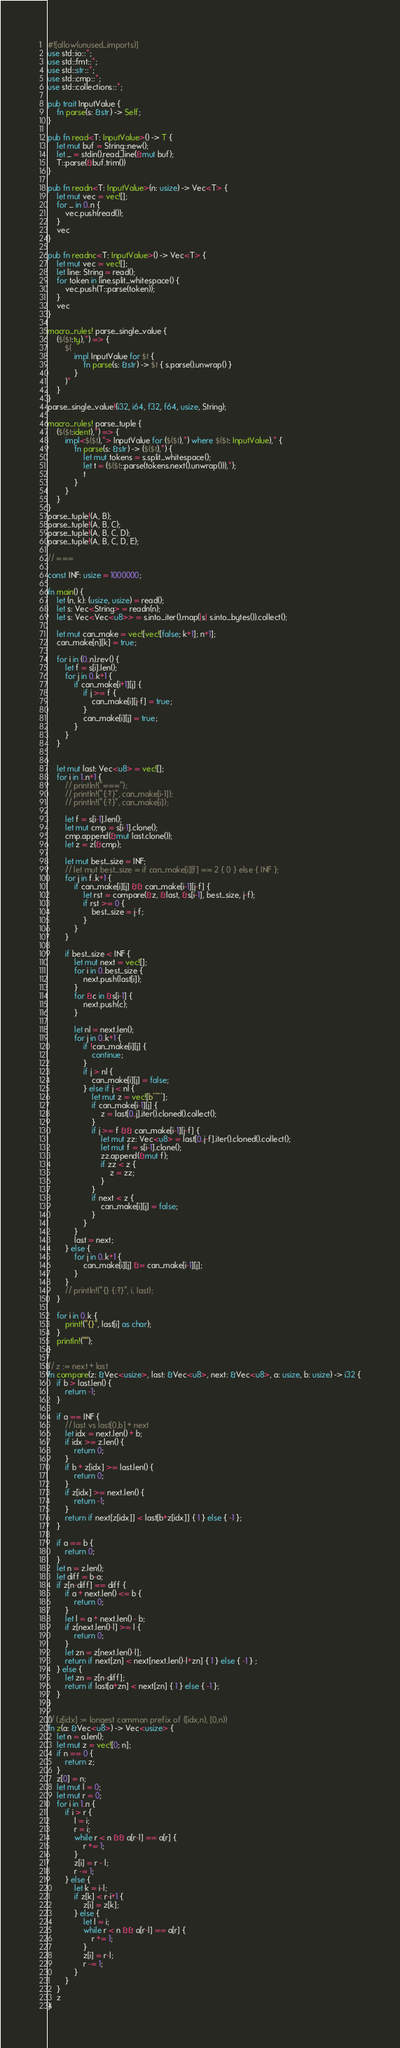<code> <loc_0><loc_0><loc_500><loc_500><_Rust_>#![allow(unused_imports)]
use std::io::*;
use std::fmt::*;
use std::str::*;
use std::cmp::*;
use std::collections::*;

pub trait InputValue {
    fn parse(s: &str) -> Self;
}

pub fn read<T: InputValue>() -> T {
    let mut buf = String::new();
    let _ = stdin().read_line(&mut buf);
    T::parse(&buf.trim())
}

pub fn readn<T: InputValue>(n: usize) -> Vec<T> {
    let mut vec = vec![];
    for _ in 0..n {
        vec.push(read());
    }
    vec
}

pub fn readnc<T: InputValue>() -> Vec<T> {
    let mut vec = vec![];
    let line: String = read();
    for token in line.split_whitespace() {
        vec.push(T::parse(token));
    }
    vec
}

macro_rules! parse_single_value {
    ($($t:ty),*) => {
        $(
            impl InputValue for $t {
                fn parse(s: &str) -> $t { s.parse().unwrap() }
            }
        )*
	}
}
parse_single_value!(i32, i64, f32, f64, usize, String);

macro_rules! parse_tuple {
	($($t:ident),*) => {
		impl<$($t),*> InputValue for ($($t),*) where $($t: InputValue),* {
			fn parse(s: &str) -> ($($t),*) {
				let mut tokens = s.split_whitespace();
				let t = ($($t::parse(tokens.next().unwrap())),*);
				t
			}
		}
	}
}
parse_tuple!(A, B);
parse_tuple!(A, B, C);
parse_tuple!(A, B, C, D);
parse_tuple!(A, B, C, D, E);

// ===

const INF: usize = 1000000;

fn main() {
    let (n, k): (usize, usize) = read();
    let s: Vec<String> = readn(n);
    let s: Vec<Vec<u8>> = s.into_iter().map(|s| s.into_bytes()).collect();

    let mut can_make = vec![vec![false; k+1]; n+1];
    can_make[n][k] = true;

    for i in (0..n).rev() {
        let f = s[i].len();
        for j in 0..k+1 {
            if can_make[i+1][j] {
                if j >= f {
                    can_make[i][j-f] = true;
                }
                can_make[i][j] = true;
            }
        }
    }


    let mut last: Vec<u8> = vec![];
    for i in 1..n+1 {
        // println!("===");
        // println!("{:?}", can_make[i-1]);
        // println!("{:?}", can_make[i]);

        let f = s[i-1].len();
        let mut cmp = s[i-1].clone();
        cmp.append(&mut last.clone());
        let z = z(&cmp);

        let mut best_size = INF;
        // let mut best_size = if can_make[i][f] == 2 { 0 } else { INF };
        for j in f..k+1 {
            if can_make[i][j] && can_make[i-1][j-f] {
                let rst = compare(&z, &last, &s[i-1], best_size, j-f);
                if rst >= 0 {
                    best_size = j-f;
                }
            }
        }

        if best_size < INF {
            let mut next = vec![];
            for i in 0..best_size {
                next.push(last[i]);
            }
            for &c in &s[i-1] {
                next.push(c);
            }

            let nl = next.len();
            for j in 0..k+1 {
                if !can_make[i][j] {
                    continue;
                }
                if j > nl {
                    can_make[i][j] = false;
                } else if j < nl {
                    let mut z = vec![b'~'];
                    if can_make[i-1][j] {
                        z = last[0..j].iter().cloned().collect();
                    }
                    if j >= f && can_make[i-1][j-f] {
                        let mut zz: Vec<u8> = last[0..j-f].iter().cloned().collect();
                        let mut f = s[i-1].clone();
                        zz.append(&mut f);
                        if zz < z {
                            z = zz;
                        }
                    }
                    if next < z {
                        can_make[i][j] = false;
                    }
                }
            }
            last = next;
        } else {
            for j in 0..k+1 {
                can_make[i][j] &= can_make[i-1][j];
            }
        }
        // println!("{} {:?}", i, last);
    }

    for i in 0..k {
        print!("{}", last[i] as char);
    }
    println!("");
}

// z := next + last
fn compare(z: &Vec<usize>, last: &Vec<u8>, next: &Vec<u8>, a: usize, b: usize) -> i32 {
    if b > last.len() {
        return -1;
    }

    if a == INF {
        // last vs last[0,b] + next
        let idx = next.len() + b;
        if idx >= z.len() {
            return 0;
        }
        if b + z[idx] >= last.len() {
            return 0;
        }
        if z[idx] >= next.len() {
            return -1;
        }
        return if next[z[idx]] < last[b+z[idx]] { 1 } else { -1 };
    }

    if a == b {
        return 0;
    }
    let n = z.len();
    let diff = b-a;
    if z[n-diff] == diff {
        if a + next.len() <= b {
            return 0;
        }
        let l = a + next.len() - b;
        if z[next.len()-l] >= l {
            return 0;
        }
        let zn = z[next.len()-l];
        return if next[zn] < next[next.len()-l+zn] { 1 } else { -1 } ;
    } else {
        let zn = z[n-diff];
        return if last[a+zn] < next[zn] { 1 } else { -1 };
    }
}

// (z[idx] := longest common prefix of ([idx,n), [0,n))
fn z(a: &Vec<u8>) -> Vec<usize> {
    let n = a.len();
    let mut z = vec![0; n];
    if n == 0 {
        return z;
    }
    z[0] = n;
    let mut l = 0;
    let mut r = 0;
    for i in 1..n {
        if i > r {
            l = i;
            r = i;
            while r < n && a[r-l] == a[r] {
                r += 1;
            }
            z[i] = r - l;
            r -= 1;
        } else {
            let k = i-l;
            if z[k] < r-i+1 {
                z[i] = z[k];
            } else {
                let l = i;
                while r < n && a[r-l] == a[r] {
                    r += 1;
                }
                z[i] = r-l;
                r -= 1;
            }
        }
    }
    z
}
</code> 